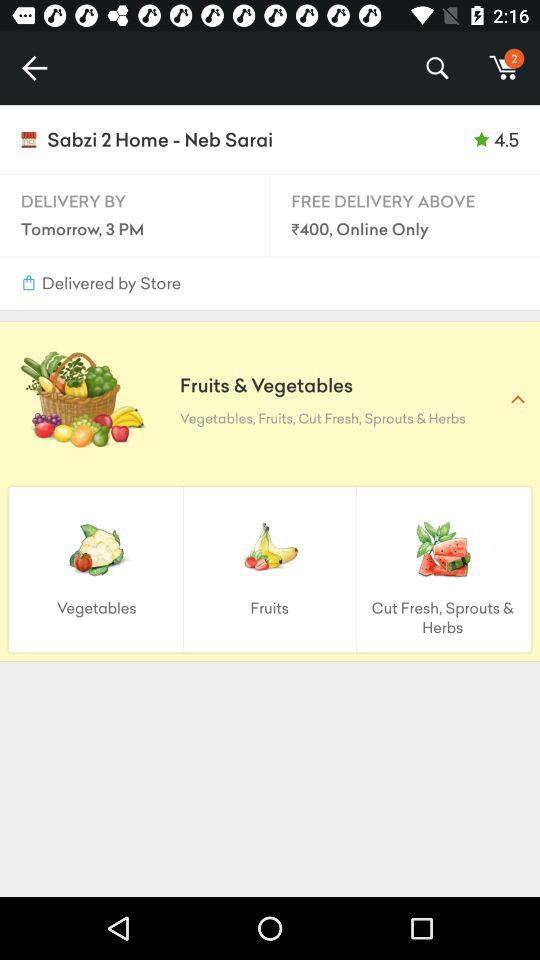How many items are in the cart?
Answer the question using a single word or phrase. 2 